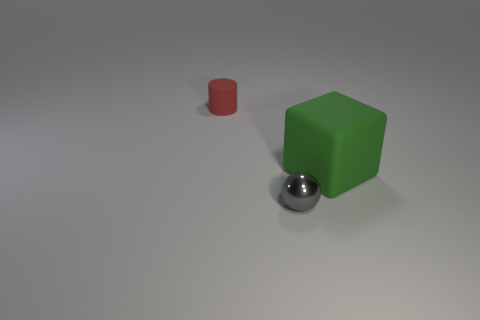Is there anything else that has the same material as the tiny gray ball?
Your answer should be very brief. No. Is there any other thing that is the same size as the green matte object?
Your answer should be very brief. No. Does the big object have the same color as the small object right of the tiny red matte object?
Provide a succinct answer. No. There is a tiny object left of the small gray metallic object; what is it made of?
Give a very brief answer. Rubber. Is there a matte sphere that has the same color as the tiny cylinder?
Your answer should be very brief. No. The cylinder that is the same size as the gray ball is what color?
Your answer should be very brief. Red. How many large things are either green matte things or cyan matte objects?
Your answer should be compact. 1. Is the number of metal objects behind the red rubber object the same as the number of small gray things behind the large green rubber cube?
Give a very brief answer. Yes. How many green things have the same size as the gray metallic object?
Keep it short and to the point. 0. How many gray objects are either tiny rubber cylinders or shiny cylinders?
Your answer should be very brief. 0. 